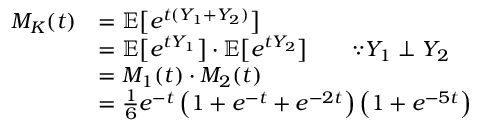Convert formula to latex. <formula><loc_0><loc_0><loc_500><loc_500>\begin{array} { r l } { M _ { K } ( t ) } & { = \mathbb { E } \left [ e ^ { t ( Y _ { 1 } + Y _ { 2 } ) } \right ] } \\ & { = \mathbb { E } \left [ e ^ { t Y _ { 1 } } \right ] \cdot \mathbb { E } \left [ e ^ { t Y _ { 2 } } \right ] \quad \because Y _ { 1 } \perp Y _ { 2 } } \\ & { = M _ { 1 } ( t ) \cdot M _ { 2 } ( t ) } \\ & { = \frac { 1 } { 6 } e ^ { - t } \left ( 1 + e ^ { - t } + e ^ { - 2 t } \right ) \left ( 1 + e ^ { - 5 t } \right ) } \end{array}</formula> 